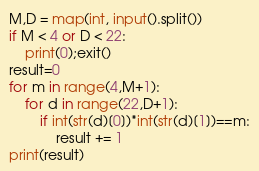Convert code to text. <code><loc_0><loc_0><loc_500><loc_500><_Python_>M,D = map(int, input().split())
if M < 4 or D < 22:
    print(0);exit()
result=0
for m in range(4,M+1):
    for d in range(22,D+1):
        if int(str(d)[0])*int(str(d)[1])==m:
            result += 1
print(result)</code> 